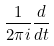<formula> <loc_0><loc_0><loc_500><loc_500>\frac { 1 } { 2 \pi i } \frac { d } { d t }</formula> 